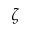<formula> <loc_0><loc_0><loc_500><loc_500>\zeta</formula> 